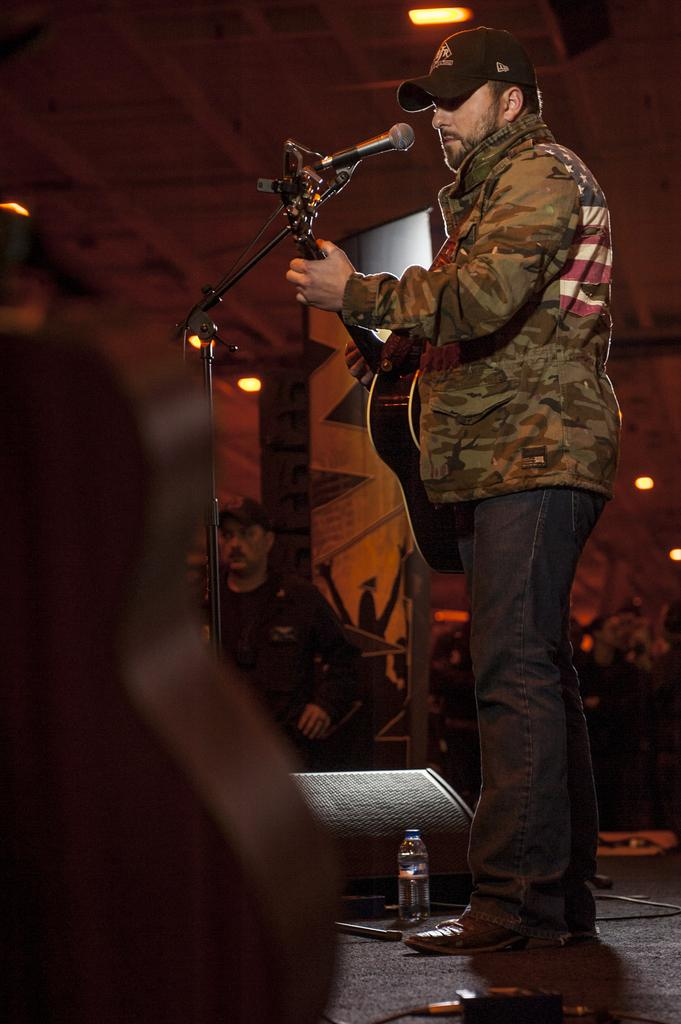What is the person in the image doing? The person is playing a guitar. What type of clothing is the person wearing? The person is wearing black jeans. What object is in front of the person? There is a microphone in front of the person. Can you describe the person in the background? The person in the background is wearing a black shirt. What type of crown is the actor wearing in the image? There is no actor or crown present in the image. 